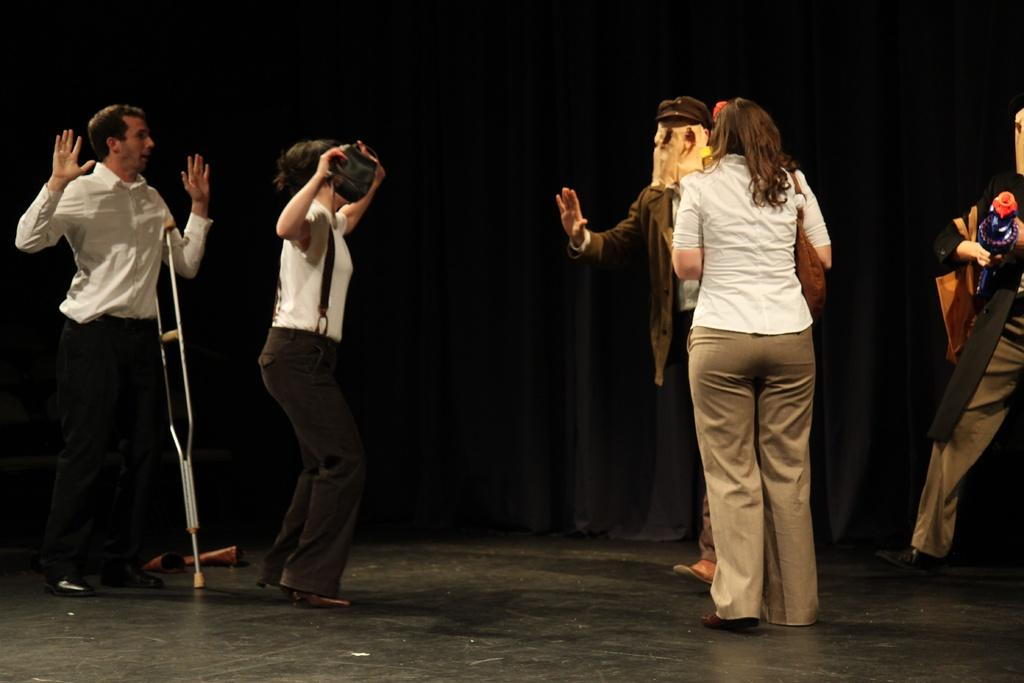How many people are in the image? There are people in the image, but the exact number is not specified. What are the people doing in the image? The people are standing and performing an act. Where is the act being performed? The act is being performed on a stage. What type of line can be seen connecting the people in the image? There is no line connecting the people in the image. How many flights are visible in the image? There is no reference to any flights in the image. 